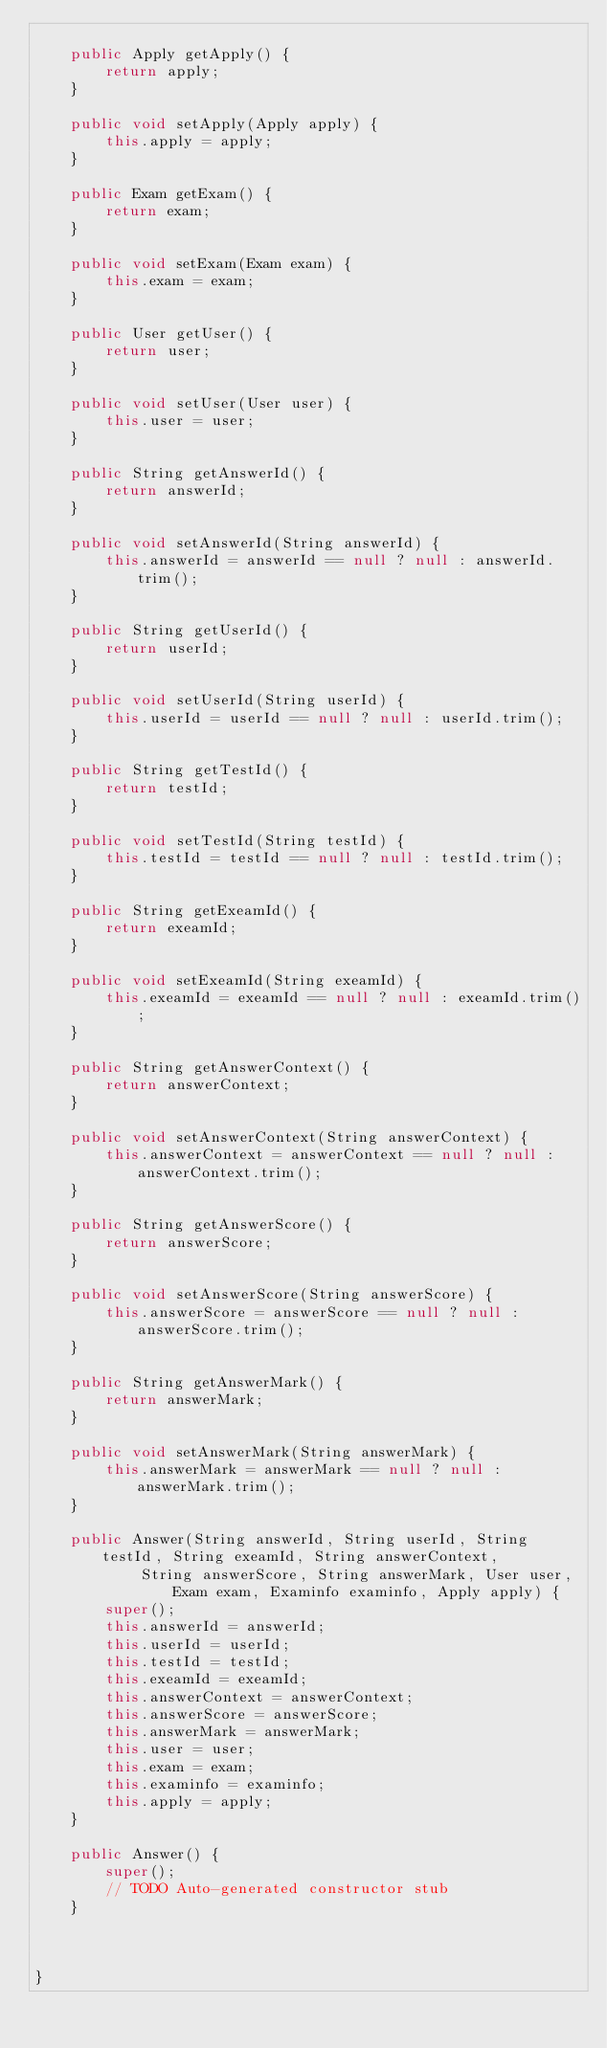<code> <loc_0><loc_0><loc_500><loc_500><_Java_>
	public Apply getApply() {
		return apply;
	}

	public void setApply(Apply apply) {
		this.apply = apply;
	}

	public Exam getExam() {
		return exam;
	}

	public void setExam(Exam exam) {
		this.exam = exam;
	}

	public User getUser() {
		return user;
	}

	public void setUser(User user) {
		this.user = user;
	}

	public String getAnswerId() {
        return answerId;
    }

    public void setAnswerId(String answerId) {
        this.answerId = answerId == null ? null : answerId.trim();
    }

    public String getUserId() {
        return userId;
    }

    public void setUserId(String userId) {
        this.userId = userId == null ? null : userId.trim();
    }

    public String getTestId() {
        return testId;
    }

    public void setTestId(String testId) {
        this.testId = testId == null ? null : testId.trim();
    }

    public String getExeamId() {
        return exeamId;
    }

    public void setExeamId(String exeamId) {
        this.exeamId = exeamId == null ? null : exeamId.trim();
    }

    public String getAnswerContext() {
        return answerContext;
    }

    public void setAnswerContext(String answerContext) {
        this.answerContext = answerContext == null ? null : answerContext.trim();
    }

    public String getAnswerScore() {
        return answerScore;
    }

    public void setAnswerScore(String answerScore) {
        this.answerScore = answerScore == null ? null : answerScore.trim();
    }

    public String getAnswerMark() {
        return answerMark;
    }

    public void setAnswerMark(String answerMark) {
        this.answerMark = answerMark == null ? null : answerMark.trim();
    }

	public Answer(String answerId, String userId, String testId, String exeamId, String answerContext,
			String answerScore, String answerMark, User user, Exam exam, Examinfo examinfo, Apply apply) {
		super();
		this.answerId = answerId;
		this.userId = userId;
		this.testId = testId;
		this.exeamId = exeamId;
		this.answerContext = answerContext;
		this.answerScore = answerScore;
		this.answerMark = answerMark;
		this.user = user;
		this.exam = exam;
		this.examinfo = examinfo;
		this.apply = apply;
	}

	public Answer() {
		super();
		// TODO Auto-generated constructor stub
	}

	
    
}</code> 